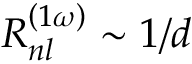Convert formula to latex. <formula><loc_0><loc_0><loc_500><loc_500>R _ { n l } ^ { \left ( 1 \omega \right ) } \sim 1 / d</formula> 